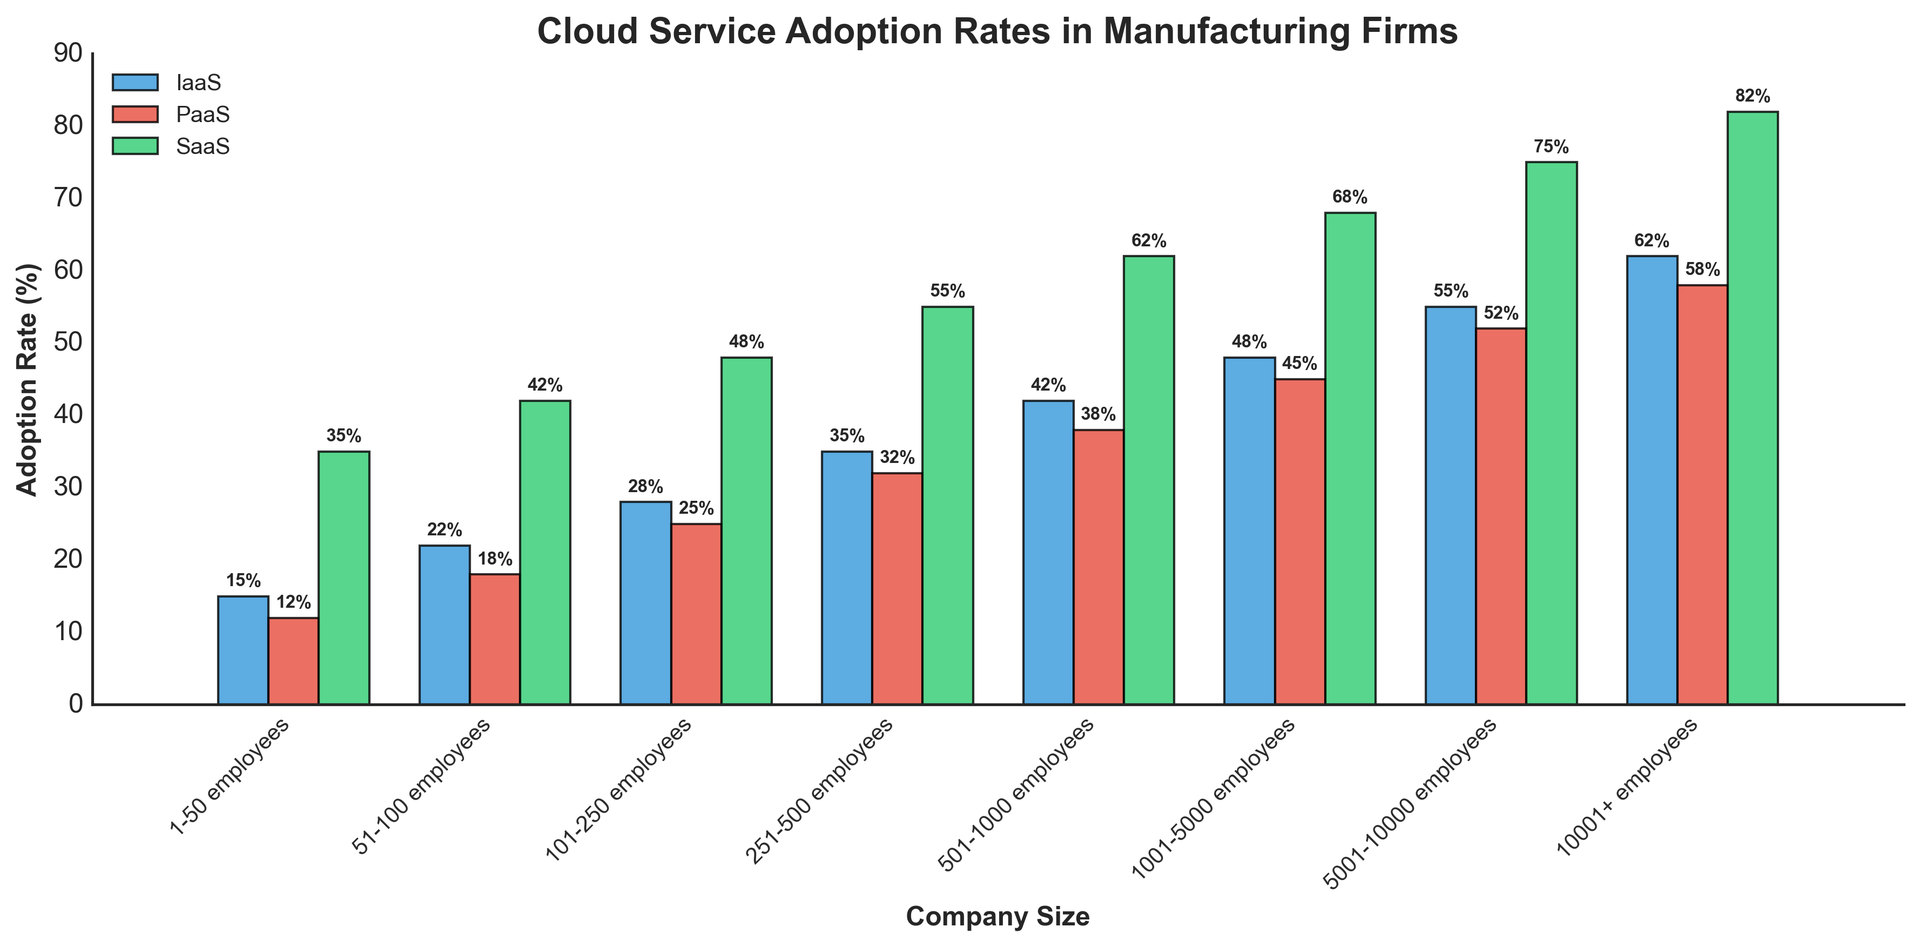What is the adoption rate of IaaS for companies with 251-500 employees? Look at the bar labeled "251-500 employees" in the blue (IaaS) category. The height of the bar will give the adoption rate.
Answer: 35% Which company size category has the highest PaaS adoption rate? Identify the highest red bar (PaaS) and check the corresponding company size label.
Answer: 10001+ employees What's the difference in SaaS adoption rates between companies with 51-100 employees and 501-1000 employees? Find the heights of the green bars for the two specified company sizes and subtract the smaller from the larger.
Answer: 62% - 42% = 20% What is the average adoption rate of IaaS for companies with 1-50 and 51-100 employees? Find the adoption rates for both sizes in the blue bars and calculate the average.
Answer: (15% + 22%) / 2 = 18.5% Compare the adoption rates of PaaS and SaaS for companies with 1001-5000 employees. Which is higher and by how much? Look at the heights of the red (PaaS) and green (SaaS) bars for 1001-5000 employees and subtract the PaaS adoption rate from the SaaS adoption rate.
Answer: SaaS is higher by 68% - 45% = 23% Which cloud service has the steepest increase in adoption rate as company size increases from 1-50 employees to 10001+ employees? Compare the increases in adoption rates for all three services from the smallest to the largest company sizes. Calculate the differences for IaaS, PaaS, and SaaS.
Answer: IaaS: 62% - 15% = 47%, PaaS: 58% - 12% = 46%, SaaS: 82% - 35% = 47%, Tie between IaaS and SaaS by 47% For companies with 5001-10000 employees, what is the total adoption rate of IaaS, PaaS, and SaaS? Sum the heights of the blue, red, and green bars for 5001-10000 employees.
Answer: 55% + 52% + 75% = 182% How does the adoption rate of SaaS compare between the smallest and largest company sizes? Compare the heights of the green bars for the smallest and largest company sizes.
Answer: 82% - 35% = 47% higher for 10001+ employees For the company size of 101-250 employees, which cloud service has the lowest adoption rate and what is it? Compare the heights of the three bars (blue, red, green) for 101-250 employees and identify the smallest one.
Answer: PaaS at 25% 